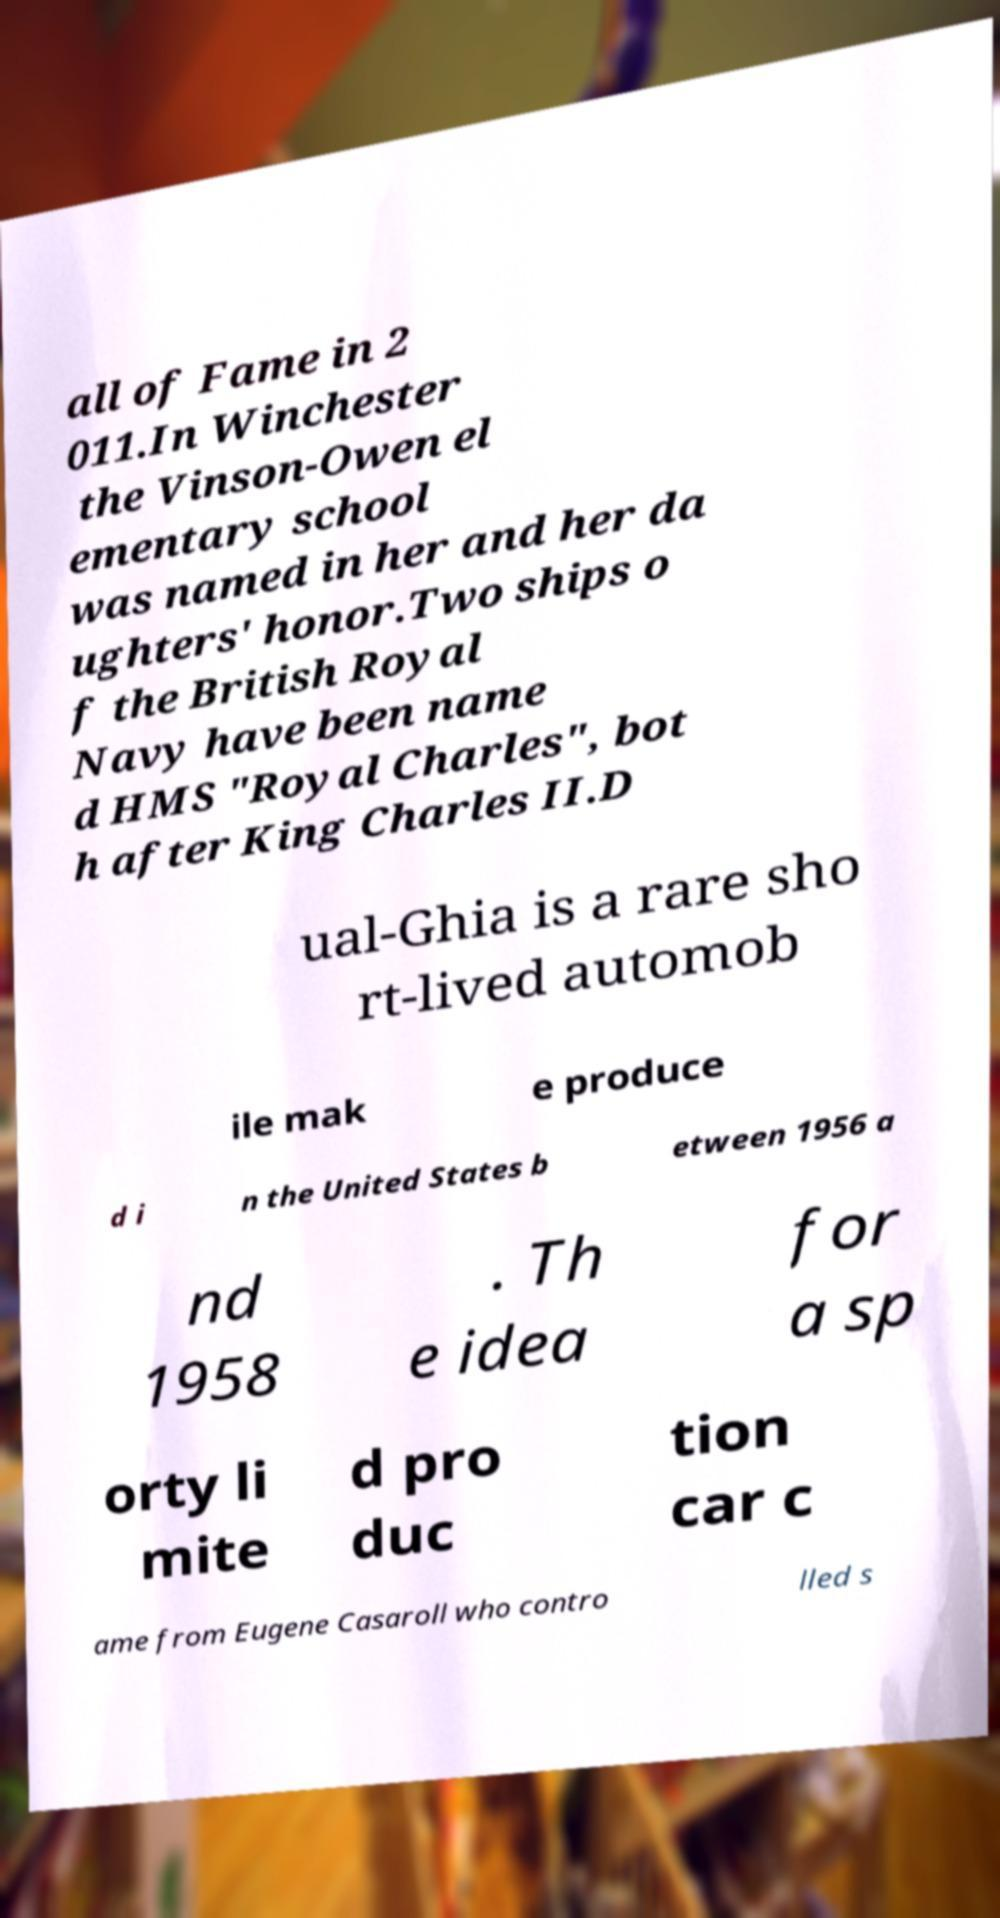What messages or text are displayed in this image? I need them in a readable, typed format. all of Fame in 2 011.In Winchester the Vinson-Owen el ementary school was named in her and her da ughters' honor.Two ships o f the British Royal Navy have been name d HMS "Royal Charles", bot h after King Charles II.D ual-Ghia is a rare sho rt-lived automob ile mak e produce d i n the United States b etween 1956 a nd 1958 . Th e idea for a sp orty li mite d pro duc tion car c ame from Eugene Casaroll who contro lled s 